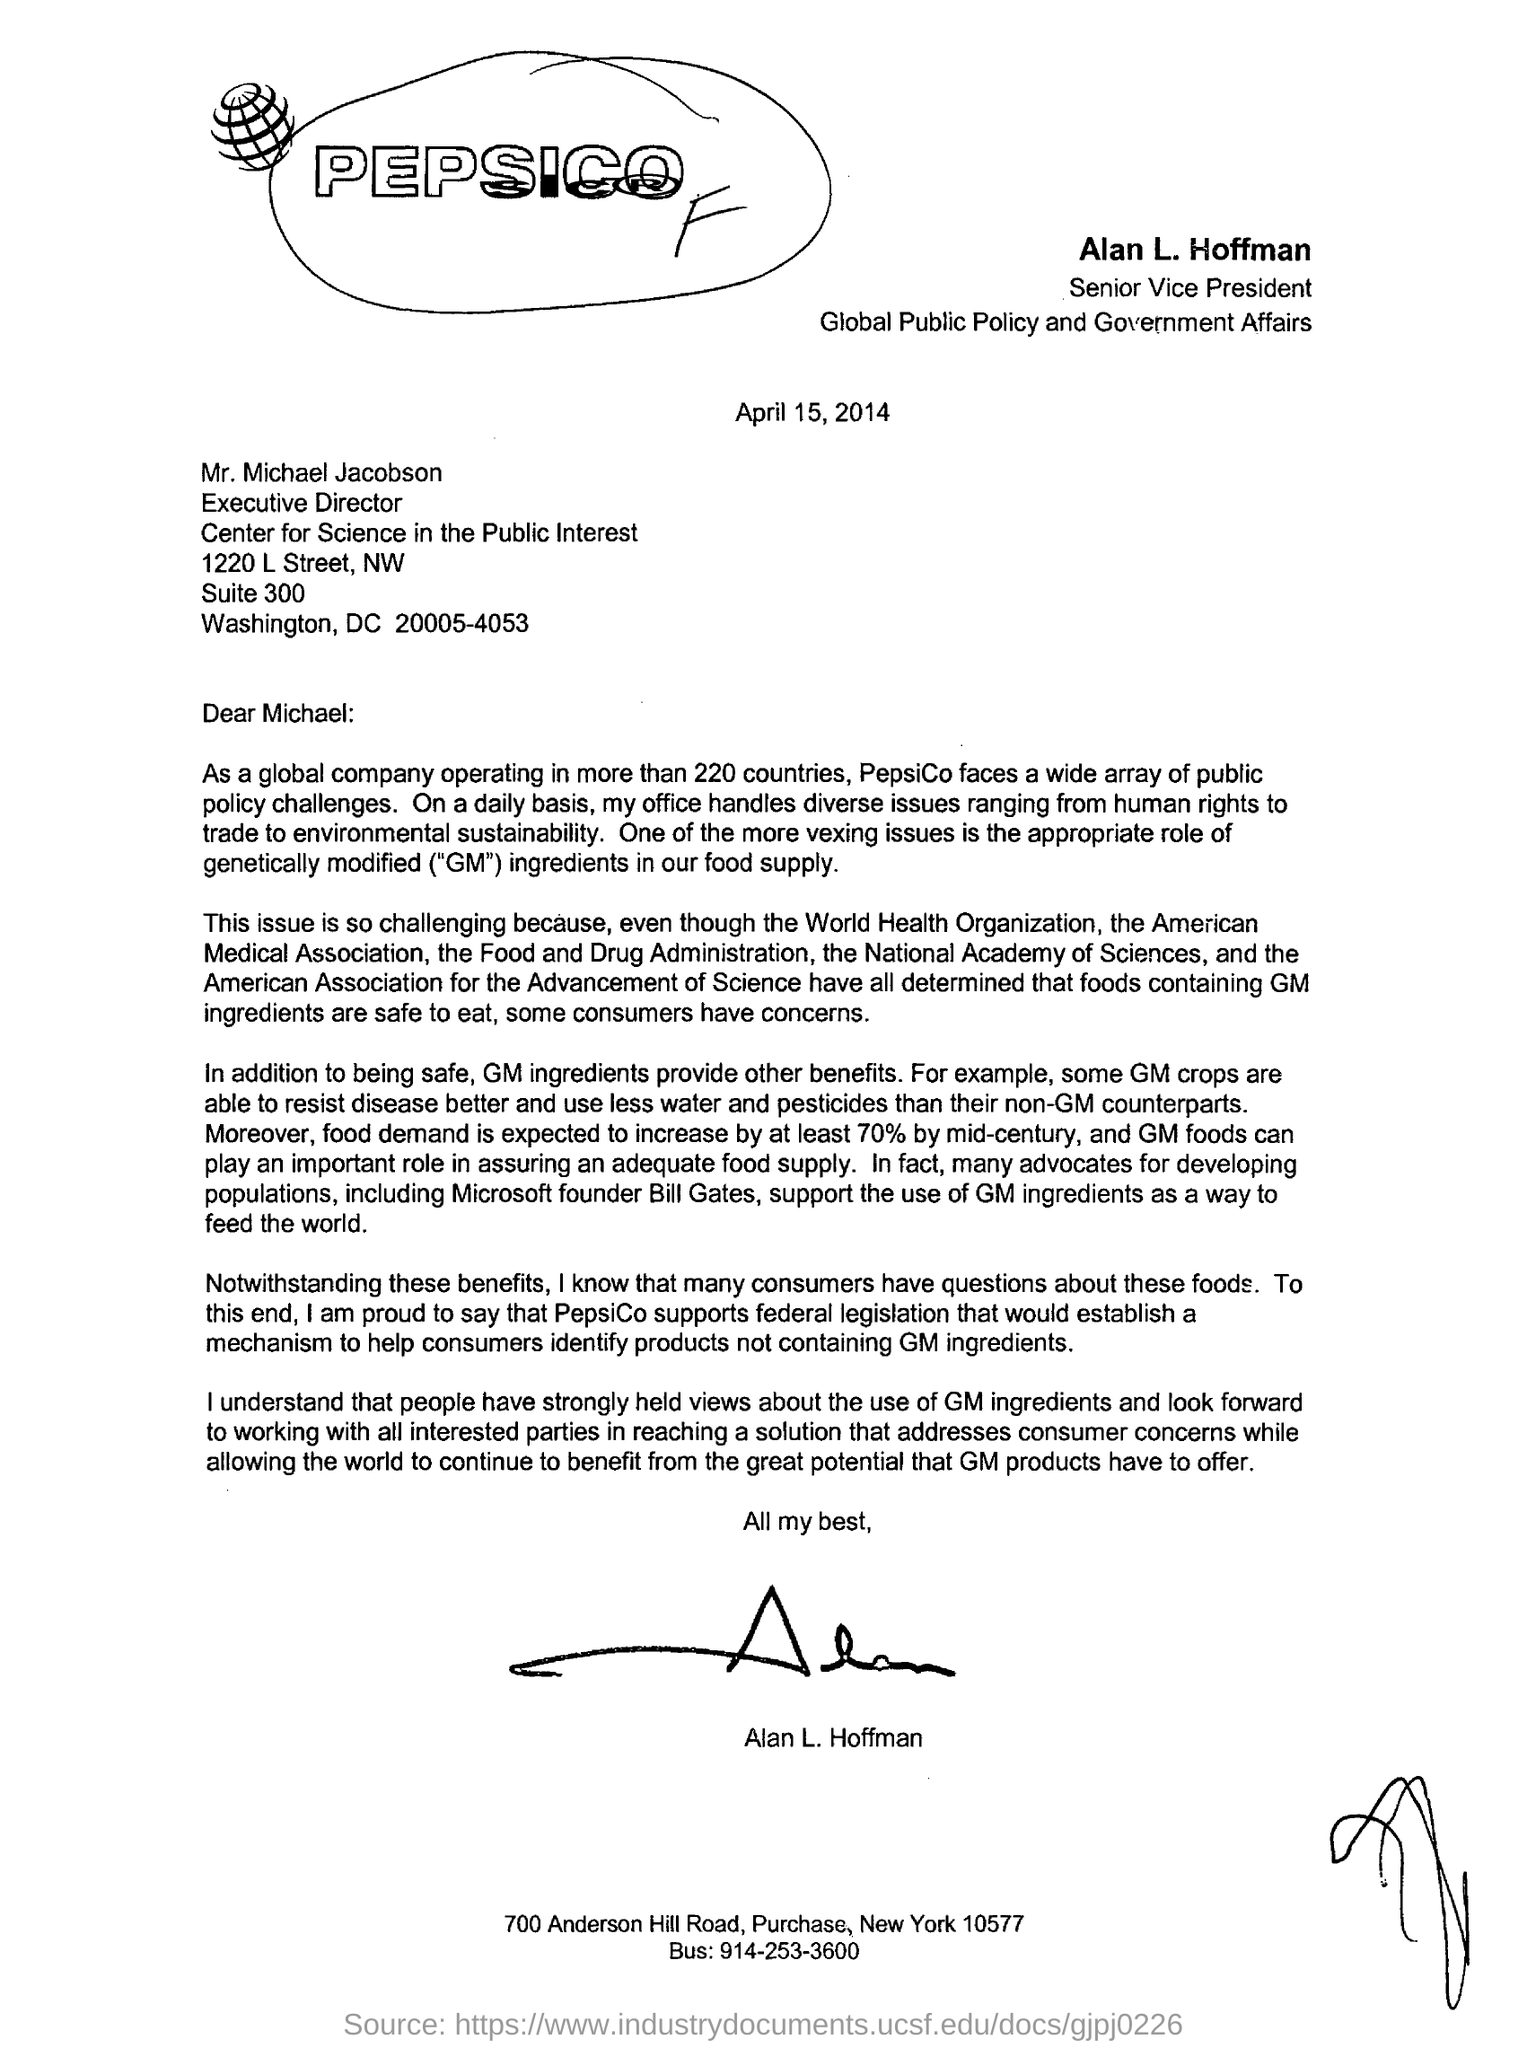Draw attention to some important aspects in this diagram. Alan L. Hoffman is the Senior Vice President. The date mentioned in the letter is April 15, 2014. The executive director is Mr. Michael Jacobson. Alan L. Hoffman is currently employed in the field of global public policy and government affairs. Our global company operates in more than 220 countries worldwide. 